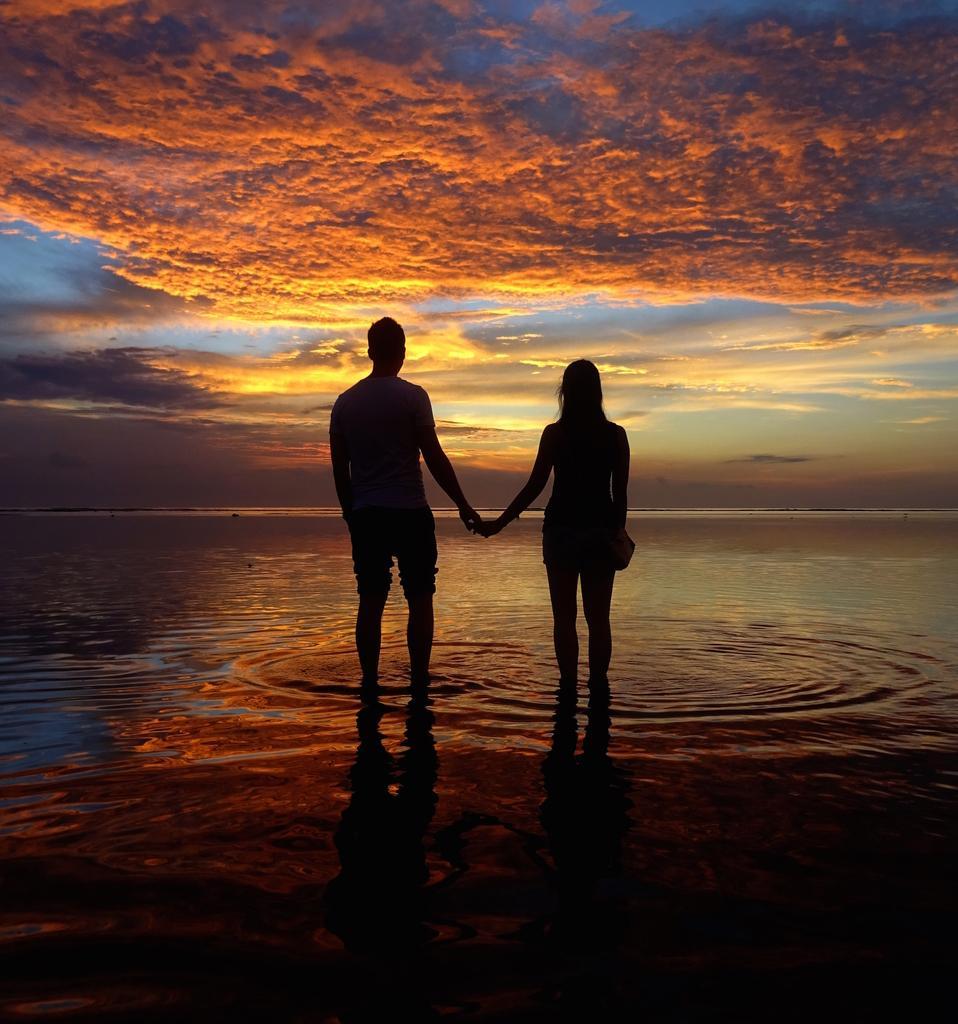Please provide a concise description of this image. In this image there are two persons standing and holding their hands , and in the background there is water, sky. 